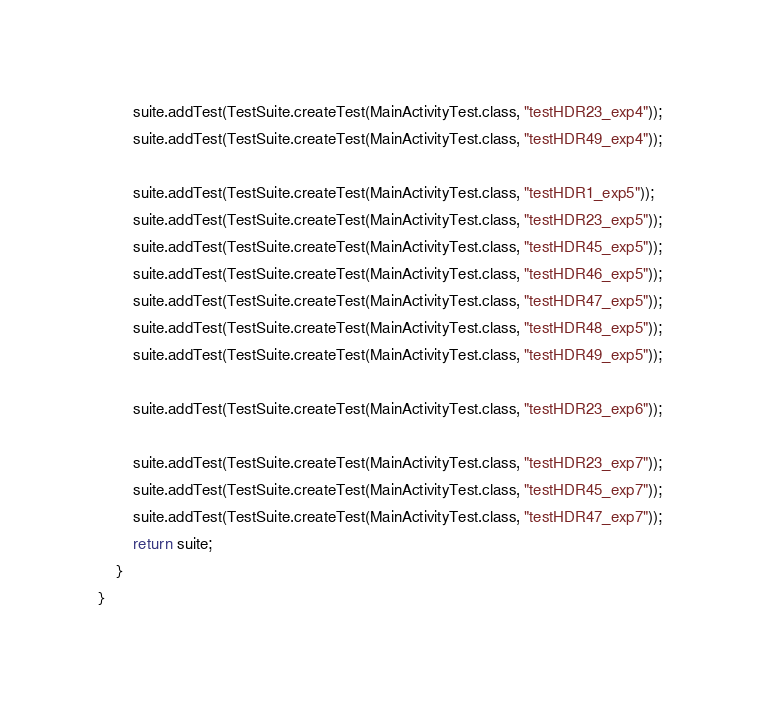<code> <loc_0><loc_0><loc_500><loc_500><_Java_>
		suite.addTest(TestSuite.createTest(MainActivityTest.class, "testHDR23_exp4"));
		suite.addTest(TestSuite.createTest(MainActivityTest.class, "testHDR49_exp4"));

		suite.addTest(TestSuite.createTest(MainActivityTest.class, "testHDR1_exp5"));
		suite.addTest(TestSuite.createTest(MainActivityTest.class, "testHDR23_exp5"));
		suite.addTest(TestSuite.createTest(MainActivityTest.class, "testHDR45_exp5"));
		suite.addTest(TestSuite.createTest(MainActivityTest.class, "testHDR46_exp5"));
		suite.addTest(TestSuite.createTest(MainActivityTest.class, "testHDR47_exp5"));
		suite.addTest(TestSuite.createTest(MainActivityTest.class, "testHDR48_exp5"));
		suite.addTest(TestSuite.createTest(MainActivityTest.class, "testHDR49_exp5"));

		suite.addTest(TestSuite.createTest(MainActivityTest.class, "testHDR23_exp6"));

		suite.addTest(TestSuite.createTest(MainActivityTest.class, "testHDR23_exp7"));
		suite.addTest(TestSuite.createTest(MainActivityTest.class, "testHDR45_exp7"));
		suite.addTest(TestSuite.createTest(MainActivityTest.class, "testHDR47_exp7"));
        return suite;
    }
}
</code> 